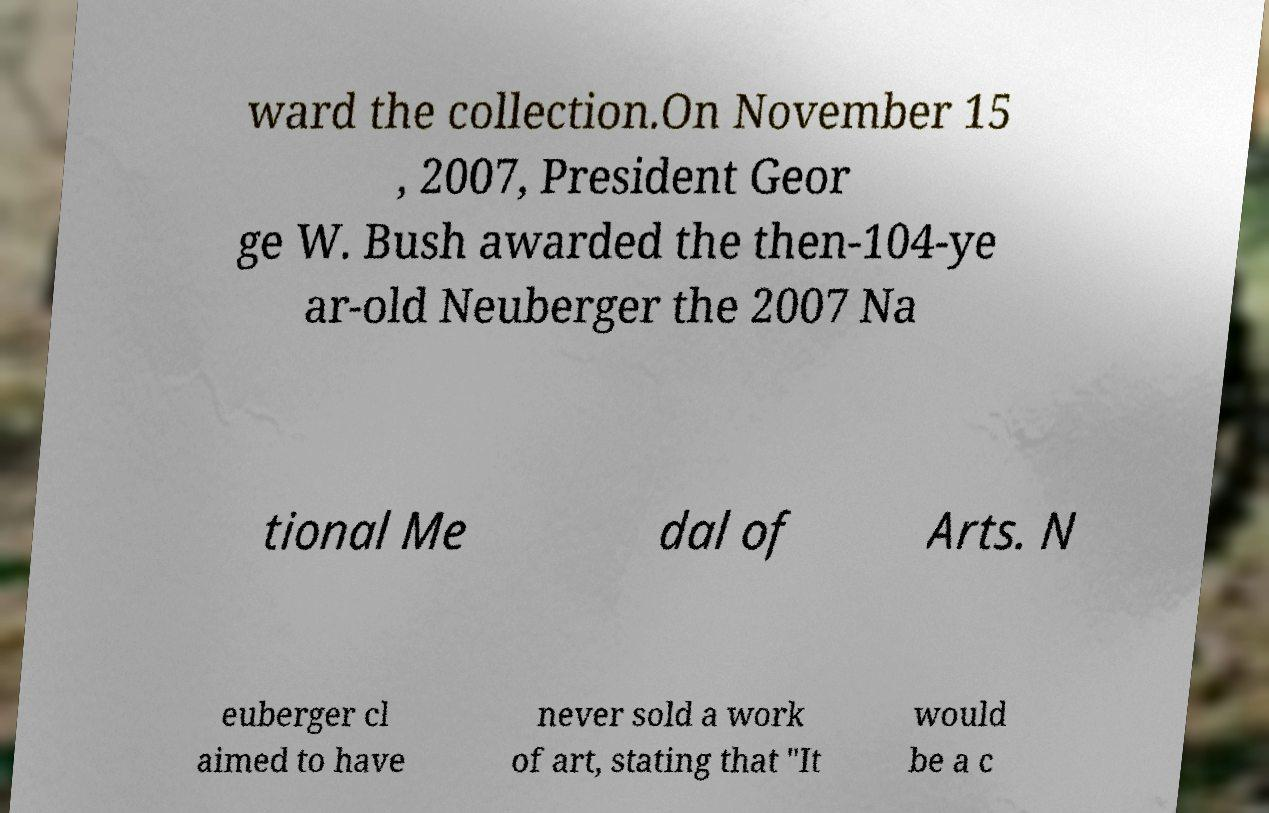There's text embedded in this image that I need extracted. Can you transcribe it verbatim? ward the collection.On November 15 , 2007, President Geor ge W. Bush awarded the then-104-ye ar-old Neuberger the 2007 Na tional Me dal of Arts. N euberger cl aimed to have never sold a work of art, stating that "It would be a c 